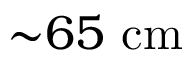<formula> <loc_0><loc_0><loc_500><loc_500>{ \sim } 6 5 c m</formula> 